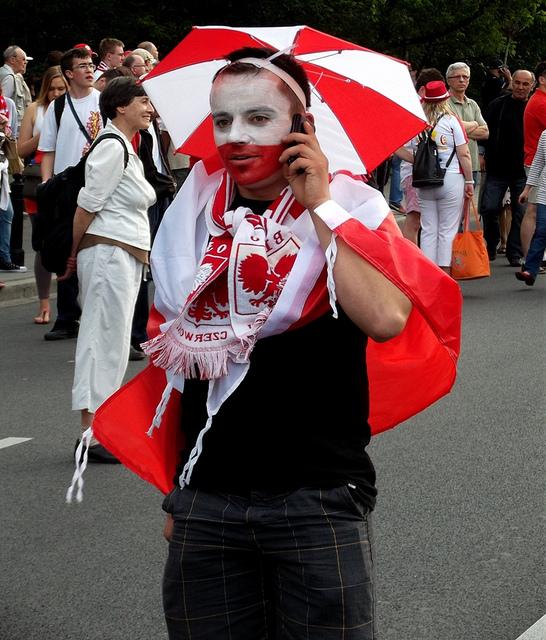What is the pattern called on the man's pants?
Quick response, please. Plaid. What game is this person watching?
Write a very short answer. Soccer. What season is this?
Be succinct. Summer. What color is the umbrella?
Concise answer only. Red and white. What is the man in red doing with his left hand?
Concise answer only. Talking on cell phone. Is an umbrella visible?
Concise answer only. Yes. 